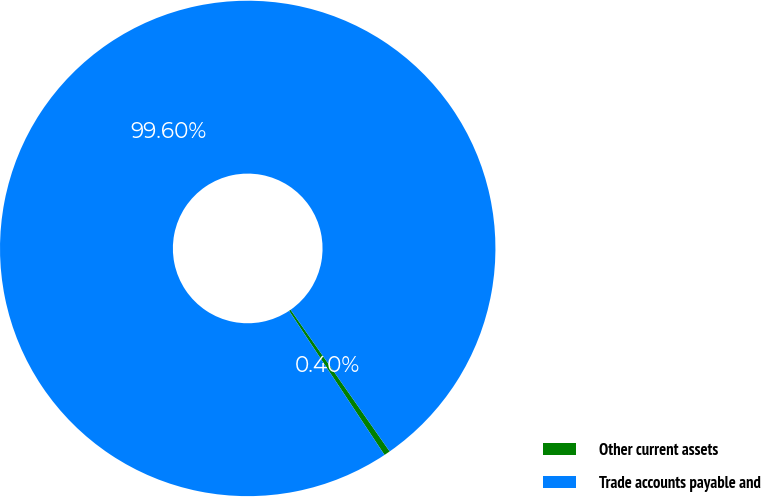Convert chart to OTSL. <chart><loc_0><loc_0><loc_500><loc_500><pie_chart><fcel>Other current assets<fcel>Trade accounts payable and<nl><fcel>0.4%<fcel>99.6%<nl></chart> 